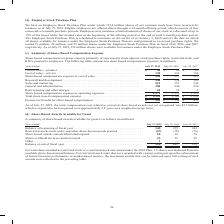According to Cisco Systems's financial document, What are the units used in the table? According to the financial document, millions. The relevant text states: "e summarizes share-based compensation expense (in millions):..." Also, What was the amount of Other share-based awards in 2019? According to the financial document, 1 (in millions). The relevant text states: "ased compensation expense in operating expenses . 1,371 1,372 1,310 Total share-based compensation expense . $ 1,591 $ 1,599 $ 1,529 Income tax benefit..." Also, What was the amount of Shares withheld for taxes and not issued in 2017? According to the financial document, 28 (in millions). The relevant text states: "Years Ended July 27, 2019 July 28, 2018 July 29, 2017 Cost of sales—product . $ 90 $ 94 $ 85 Cost of sales—service . 130 133 134 Shar..." Also, can you calculate: What was the change in Balance at beginning of fiscal year between 2017 and 2018? Based on the calculation: 272-242, the result is 30 (in millions). This is based on the information: "017 Balance at beginning of fiscal year . 245 272 242 Restricted stock, stock units, and other share-based awards granted . (67) (70) (76) Share-based aw 9, 2017 Balance at beginning of fiscal year . ..." The key data points involved are: 242, 272. Also, How many years did Shares withheld for taxes and not issued exceed $20 million? Counting the relevant items in the document: 2019, 2018, 2017, I find 3 instances. The key data points involved are: 2017, 2018, 2019. Also, can you calculate: What was the percentage change in the balance at end of fiscal year between 2018 and 2019? To answer this question, I need to perform calculations using the financial data. The calculation is: (220-245)/245, which equals -10.2 (percentage). This is based on the information: "28 Other . 1 — — Balance at end of fiscal year . 220 245 272 ly 29, 2017 Balance at beginning of fiscal year . 245 272 242 Restricted stock, stock units, and other share-based awards granted . (67) (7..." The key data points involved are: 220, 245. 